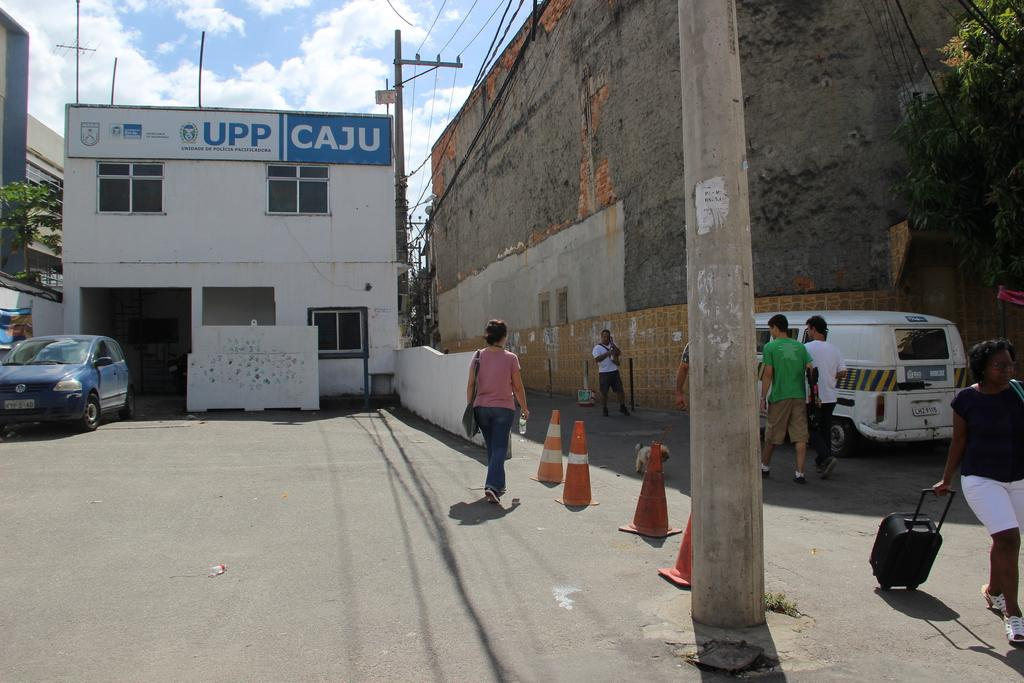Provide a one-sentence caption for the provided image. the word caju that is on a building. 